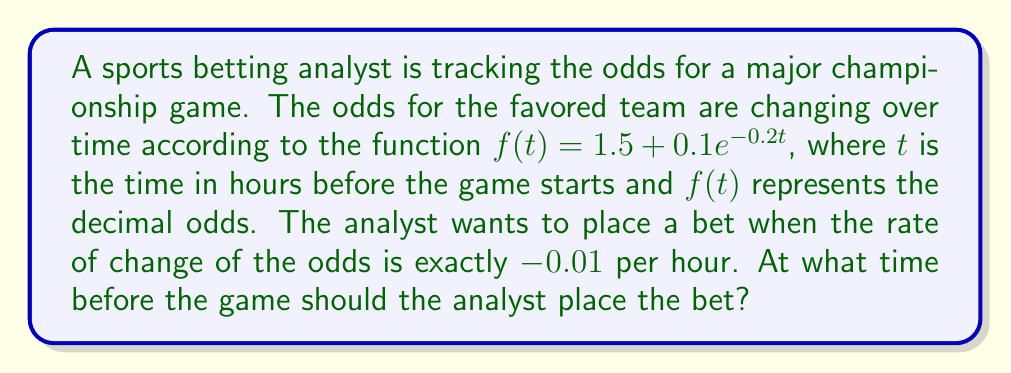Can you solve this math problem? To solve this problem, we need to follow these steps:

1) First, we need to find the rate of change of the odds function. This is given by the derivative of $f(t)$:

   $$f'(t) = \frac{d}{dt}(1.5 + 0.1e^{-0.2t}) = -0.02e^{-0.2t}$$

2) We want to find when this rate of change equals -0.01. So we set up the equation:

   $$-0.02e^{-0.2t} = -0.01$$

3) Now we solve this equation for $t$:

   $$e^{-0.2t} = 0.5$$

   Taking the natural log of both sides:

   $$-0.2t = \ln(0.5)$$

   $$t = -\frac{\ln(0.5)}{0.2}$$

4) We can simplify this further:

   $$t = -\frac{-0.693147}{0.2} \approx 3.46574$$

5) This means the analyst should place the bet approximately 3.47 hours before the game starts.

6) We can verify this by plugging the value back into the original derivative:

   $$f'(3.46574) = -0.02e^{-0.2(3.46574)} \approx -0.01$$

   Which confirms our result.
Answer: The analyst should place the bet approximately 3.47 hours before the game starts. 